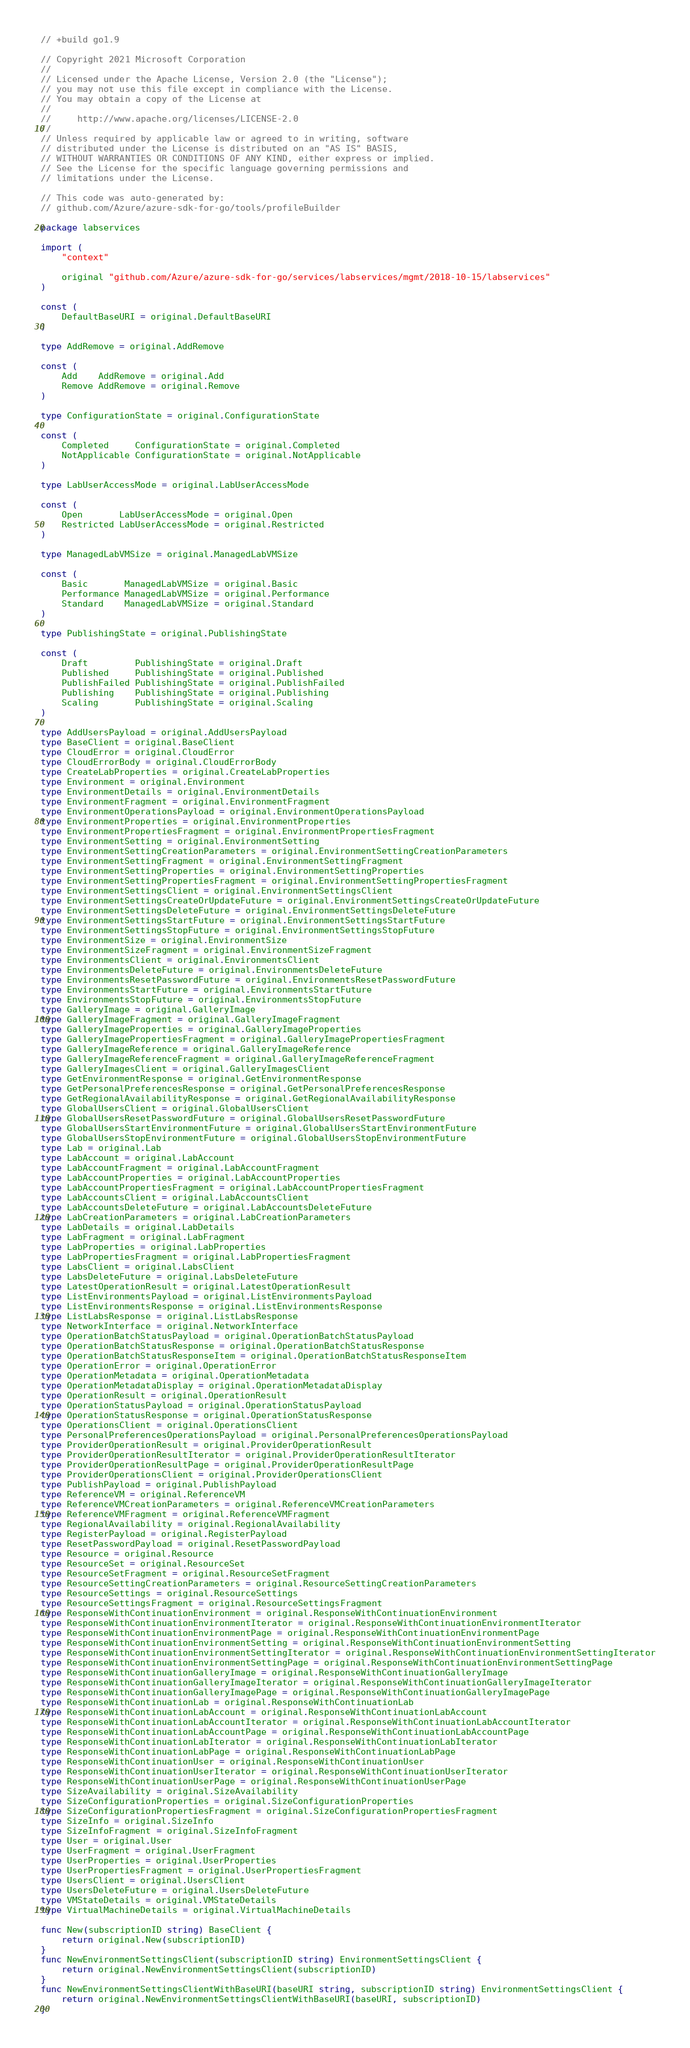<code> <loc_0><loc_0><loc_500><loc_500><_Go_>// +build go1.9

// Copyright 2021 Microsoft Corporation
//
// Licensed under the Apache License, Version 2.0 (the "License");
// you may not use this file except in compliance with the License.
// You may obtain a copy of the License at
//
//     http://www.apache.org/licenses/LICENSE-2.0
//
// Unless required by applicable law or agreed to in writing, software
// distributed under the License is distributed on an "AS IS" BASIS,
// WITHOUT WARRANTIES OR CONDITIONS OF ANY KIND, either express or implied.
// See the License for the specific language governing permissions and
// limitations under the License.

// This code was auto-generated by:
// github.com/Azure/azure-sdk-for-go/tools/profileBuilder

package labservices

import (
	"context"

	original "github.com/Azure/azure-sdk-for-go/services/labservices/mgmt/2018-10-15/labservices"
)

const (
	DefaultBaseURI = original.DefaultBaseURI
)

type AddRemove = original.AddRemove

const (
	Add    AddRemove = original.Add
	Remove AddRemove = original.Remove
)

type ConfigurationState = original.ConfigurationState

const (
	Completed     ConfigurationState = original.Completed
	NotApplicable ConfigurationState = original.NotApplicable
)

type LabUserAccessMode = original.LabUserAccessMode

const (
	Open       LabUserAccessMode = original.Open
	Restricted LabUserAccessMode = original.Restricted
)

type ManagedLabVMSize = original.ManagedLabVMSize

const (
	Basic       ManagedLabVMSize = original.Basic
	Performance ManagedLabVMSize = original.Performance
	Standard    ManagedLabVMSize = original.Standard
)

type PublishingState = original.PublishingState

const (
	Draft         PublishingState = original.Draft
	Published     PublishingState = original.Published
	PublishFailed PublishingState = original.PublishFailed
	Publishing    PublishingState = original.Publishing
	Scaling       PublishingState = original.Scaling
)

type AddUsersPayload = original.AddUsersPayload
type BaseClient = original.BaseClient
type CloudError = original.CloudError
type CloudErrorBody = original.CloudErrorBody
type CreateLabProperties = original.CreateLabProperties
type Environment = original.Environment
type EnvironmentDetails = original.EnvironmentDetails
type EnvironmentFragment = original.EnvironmentFragment
type EnvironmentOperationsPayload = original.EnvironmentOperationsPayload
type EnvironmentProperties = original.EnvironmentProperties
type EnvironmentPropertiesFragment = original.EnvironmentPropertiesFragment
type EnvironmentSetting = original.EnvironmentSetting
type EnvironmentSettingCreationParameters = original.EnvironmentSettingCreationParameters
type EnvironmentSettingFragment = original.EnvironmentSettingFragment
type EnvironmentSettingProperties = original.EnvironmentSettingProperties
type EnvironmentSettingPropertiesFragment = original.EnvironmentSettingPropertiesFragment
type EnvironmentSettingsClient = original.EnvironmentSettingsClient
type EnvironmentSettingsCreateOrUpdateFuture = original.EnvironmentSettingsCreateOrUpdateFuture
type EnvironmentSettingsDeleteFuture = original.EnvironmentSettingsDeleteFuture
type EnvironmentSettingsStartFuture = original.EnvironmentSettingsStartFuture
type EnvironmentSettingsStopFuture = original.EnvironmentSettingsStopFuture
type EnvironmentSize = original.EnvironmentSize
type EnvironmentSizeFragment = original.EnvironmentSizeFragment
type EnvironmentsClient = original.EnvironmentsClient
type EnvironmentsDeleteFuture = original.EnvironmentsDeleteFuture
type EnvironmentsResetPasswordFuture = original.EnvironmentsResetPasswordFuture
type EnvironmentsStartFuture = original.EnvironmentsStartFuture
type EnvironmentsStopFuture = original.EnvironmentsStopFuture
type GalleryImage = original.GalleryImage
type GalleryImageFragment = original.GalleryImageFragment
type GalleryImageProperties = original.GalleryImageProperties
type GalleryImagePropertiesFragment = original.GalleryImagePropertiesFragment
type GalleryImageReference = original.GalleryImageReference
type GalleryImageReferenceFragment = original.GalleryImageReferenceFragment
type GalleryImagesClient = original.GalleryImagesClient
type GetEnvironmentResponse = original.GetEnvironmentResponse
type GetPersonalPreferencesResponse = original.GetPersonalPreferencesResponse
type GetRegionalAvailabilityResponse = original.GetRegionalAvailabilityResponse
type GlobalUsersClient = original.GlobalUsersClient
type GlobalUsersResetPasswordFuture = original.GlobalUsersResetPasswordFuture
type GlobalUsersStartEnvironmentFuture = original.GlobalUsersStartEnvironmentFuture
type GlobalUsersStopEnvironmentFuture = original.GlobalUsersStopEnvironmentFuture
type Lab = original.Lab
type LabAccount = original.LabAccount
type LabAccountFragment = original.LabAccountFragment
type LabAccountProperties = original.LabAccountProperties
type LabAccountPropertiesFragment = original.LabAccountPropertiesFragment
type LabAccountsClient = original.LabAccountsClient
type LabAccountsDeleteFuture = original.LabAccountsDeleteFuture
type LabCreationParameters = original.LabCreationParameters
type LabDetails = original.LabDetails
type LabFragment = original.LabFragment
type LabProperties = original.LabProperties
type LabPropertiesFragment = original.LabPropertiesFragment
type LabsClient = original.LabsClient
type LabsDeleteFuture = original.LabsDeleteFuture
type LatestOperationResult = original.LatestOperationResult
type ListEnvironmentsPayload = original.ListEnvironmentsPayload
type ListEnvironmentsResponse = original.ListEnvironmentsResponse
type ListLabsResponse = original.ListLabsResponse
type NetworkInterface = original.NetworkInterface
type OperationBatchStatusPayload = original.OperationBatchStatusPayload
type OperationBatchStatusResponse = original.OperationBatchStatusResponse
type OperationBatchStatusResponseItem = original.OperationBatchStatusResponseItem
type OperationError = original.OperationError
type OperationMetadata = original.OperationMetadata
type OperationMetadataDisplay = original.OperationMetadataDisplay
type OperationResult = original.OperationResult
type OperationStatusPayload = original.OperationStatusPayload
type OperationStatusResponse = original.OperationStatusResponse
type OperationsClient = original.OperationsClient
type PersonalPreferencesOperationsPayload = original.PersonalPreferencesOperationsPayload
type ProviderOperationResult = original.ProviderOperationResult
type ProviderOperationResultIterator = original.ProviderOperationResultIterator
type ProviderOperationResultPage = original.ProviderOperationResultPage
type ProviderOperationsClient = original.ProviderOperationsClient
type PublishPayload = original.PublishPayload
type ReferenceVM = original.ReferenceVM
type ReferenceVMCreationParameters = original.ReferenceVMCreationParameters
type ReferenceVMFragment = original.ReferenceVMFragment
type RegionalAvailability = original.RegionalAvailability
type RegisterPayload = original.RegisterPayload
type ResetPasswordPayload = original.ResetPasswordPayload
type Resource = original.Resource
type ResourceSet = original.ResourceSet
type ResourceSetFragment = original.ResourceSetFragment
type ResourceSettingCreationParameters = original.ResourceSettingCreationParameters
type ResourceSettings = original.ResourceSettings
type ResourceSettingsFragment = original.ResourceSettingsFragment
type ResponseWithContinuationEnvironment = original.ResponseWithContinuationEnvironment
type ResponseWithContinuationEnvironmentIterator = original.ResponseWithContinuationEnvironmentIterator
type ResponseWithContinuationEnvironmentPage = original.ResponseWithContinuationEnvironmentPage
type ResponseWithContinuationEnvironmentSetting = original.ResponseWithContinuationEnvironmentSetting
type ResponseWithContinuationEnvironmentSettingIterator = original.ResponseWithContinuationEnvironmentSettingIterator
type ResponseWithContinuationEnvironmentSettingPage = original.ResponseWithContinuationEnvironmentSettingPage
type ResponseWithContinuationGalleryImage = original.ResponseWithContinuationGalleryImage
type ResponseWithContinuationGalleryImageIterator = original.ResponseWithContinuationGalleryImageIterator
type ResponseWithContinuationGalleryImagePage = original.ResponseWithContinuationGalleryImagePage
type ResponseWithContinuationLab = original.ResponseWithContinuationLab
type ResponseWithContinuationLabAccount = original.ResponseWithContinuationLabAccount
type ResponseWithContinuationLabAccountIterator = original.ResponseWithContinuationLabAccountIterator
type ResponseWithContinuationLabAccountPage = original.ResponseWithContinuationLabAccountPage
type ResponseWithContinuationLabIterator = original.ResponseWithContinuationLabIterator
type ResponseWithContinuationLabPage = original.ResponseWithContinuationLabPage
type ResponseWithContinuationUser = original.ResponseWithContinuationUser
type ResponseWithContinuationUserIterator = original.ResponseWithContinuationUserIterator
type ResponseWithContinuationUserPage = original.ResponseWithContinuationUserPage
type SizeAvailability = original.SizeAvailability
type SizeConfigurationProperties = original.SizeConfigurationProperties
type SizeConfigurationPropertiesFragment = original.SizeConfigurationPropertiesFragment
type SizeInfo = original.SizeInfo
type SizeInfoFragment = original.SizeInfoFragment
type User = original.User
type UserFragment = original.UserFragment
type UserProperties = original.UserProperties
type UserPropertiesFragment = original.UserPropertiesFragment
type UsersClient = original.UsersClient
type UsersDeleteFuture = original.UsersDeleteFuture
type VMStateDetails = original.VMStateDetails
type VirtualMachineDetails = original.VirtualMachineDetails

func New(subscriptionID string) BaseClient {
	return original.New(subscriptionID)
}
func NewEnvironmentSettingsClient(subscriptionID string) EnvironmentSettingsClient {
	return original.NewEnvironmentSettingsClient(subscriptionID)
}
func NewEnvironmentSettingsClientWithBaseURI(baseURI string, subscriptionID string) EnvironmentSettingsClient {
	return original.NewEnvironmentSettingsClientWithBaseURI(baseURI, subscriptionID)
}</code> 